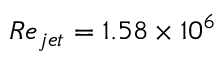Convert formula to latex. <formula><loc_0><loc_0><loc_500><loc_500>R e _ { j e t } = 1 . 5 8 \times 1 0 ^ { 6 }</formula> 